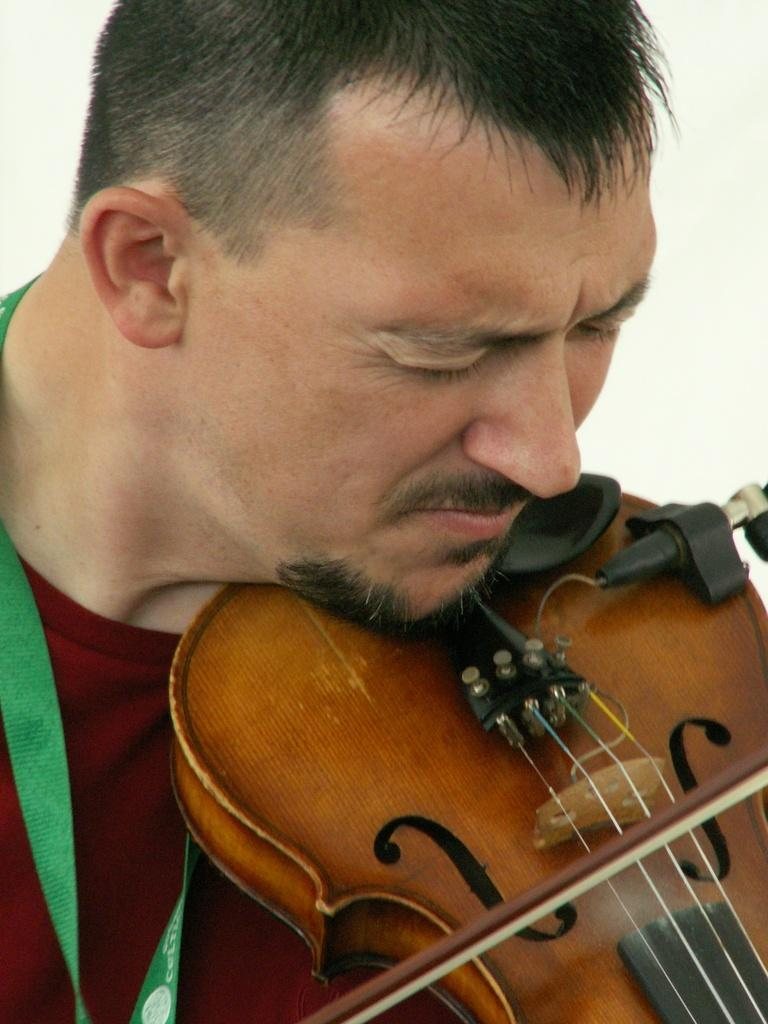What is the main subject of the image? The main subject of the image is a man. What is the man wearing in the image? The man is wearing a red t-shirt in the image. What activity is the man engaged in? The man is playing a violin in the image. Can you describe any facial features of the man? The man has a beard in the image. How many ladybugs can be seen crawling on the violin in the image? There are no ladybugs present in the image; the man is playing a violin without any insects on it. 